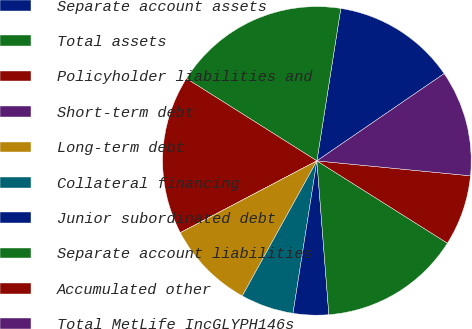<chart> <loc_0><loc_0><loc_500><loc_500><pie_chart><fcel>Separate account assets<fcel>Total assets<fcel>Policyholder liabilities and<fcel>Short-term debt<fcel>Long-term debt<fcel>Collateral financing<fcel>Junior subordinated debt<fcel>Separate account liabilities<fcel>Accumulated other<fcel>Total MetLife IncGLYPH146s<nl><fcel>12.96%<fcel>18.52%<fcel>16.67%<fcel>0.0%<fcel>9.26%<fcel>5.56%<fcel>3.71%<fcel>14.81%<fcel>7.41%<fcel>11.11%<nl></chart> 